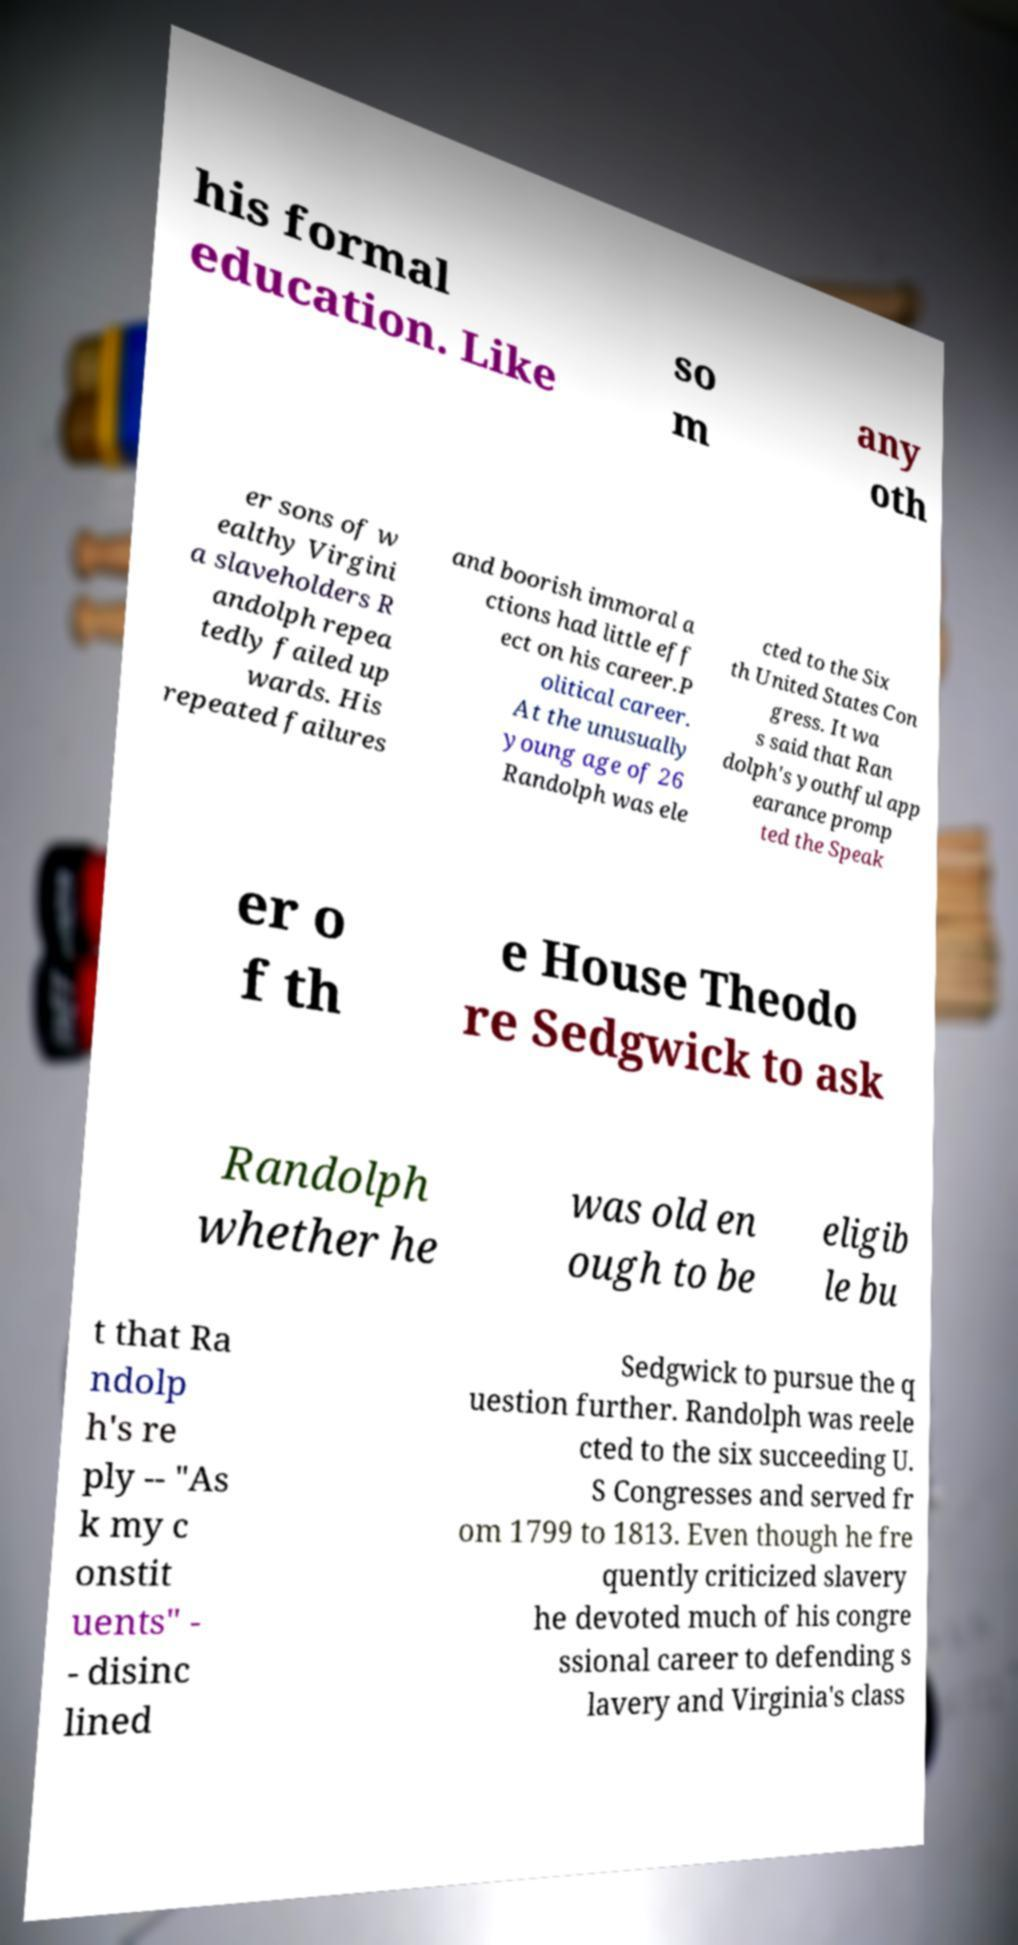There's text embedded in this image that I need extracted. Can you transcribe it verbatim? his formal education. Like so m any oth er sons of w ealthy Virgini a slaveholders R andolph repea tedly failed up wards. His repeated failures and boorish immoral a ctions had little eff ect on his career.P olitical career. At the unusually young age of 26 Randolph was ele cted to the Six th United States Con gress. It wa s said that Ran dolph's youthful app earance promp ted the Speak er o f th e House Theodo re Sedgwick to ask Randolph whether he was old en ough to be eligib le bu t that Ra ndolp h's re ply -- "As k my c onstit uents" - - disinc lined Sedgwick to pursue the q uestion further. Randolph was reele cted to the six succeeding U. S Congresses and served fr om 1799 to 1813. Even though he fre quently criticized slavery he devoted much of his congre ssional career to defending s lavery and Virginia's class 